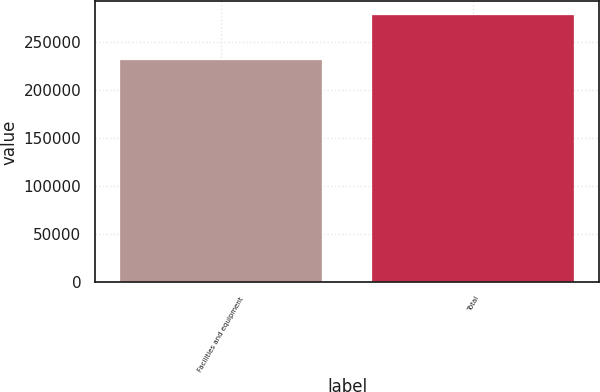Convert chart to OTSL. <chart><loc_0><loc_0><loc_500><loc_500><bar_chart><fcel>Facilities and equipment<fcel>Total<nl><fcel>231200<fcel>278386<nl></chart> 